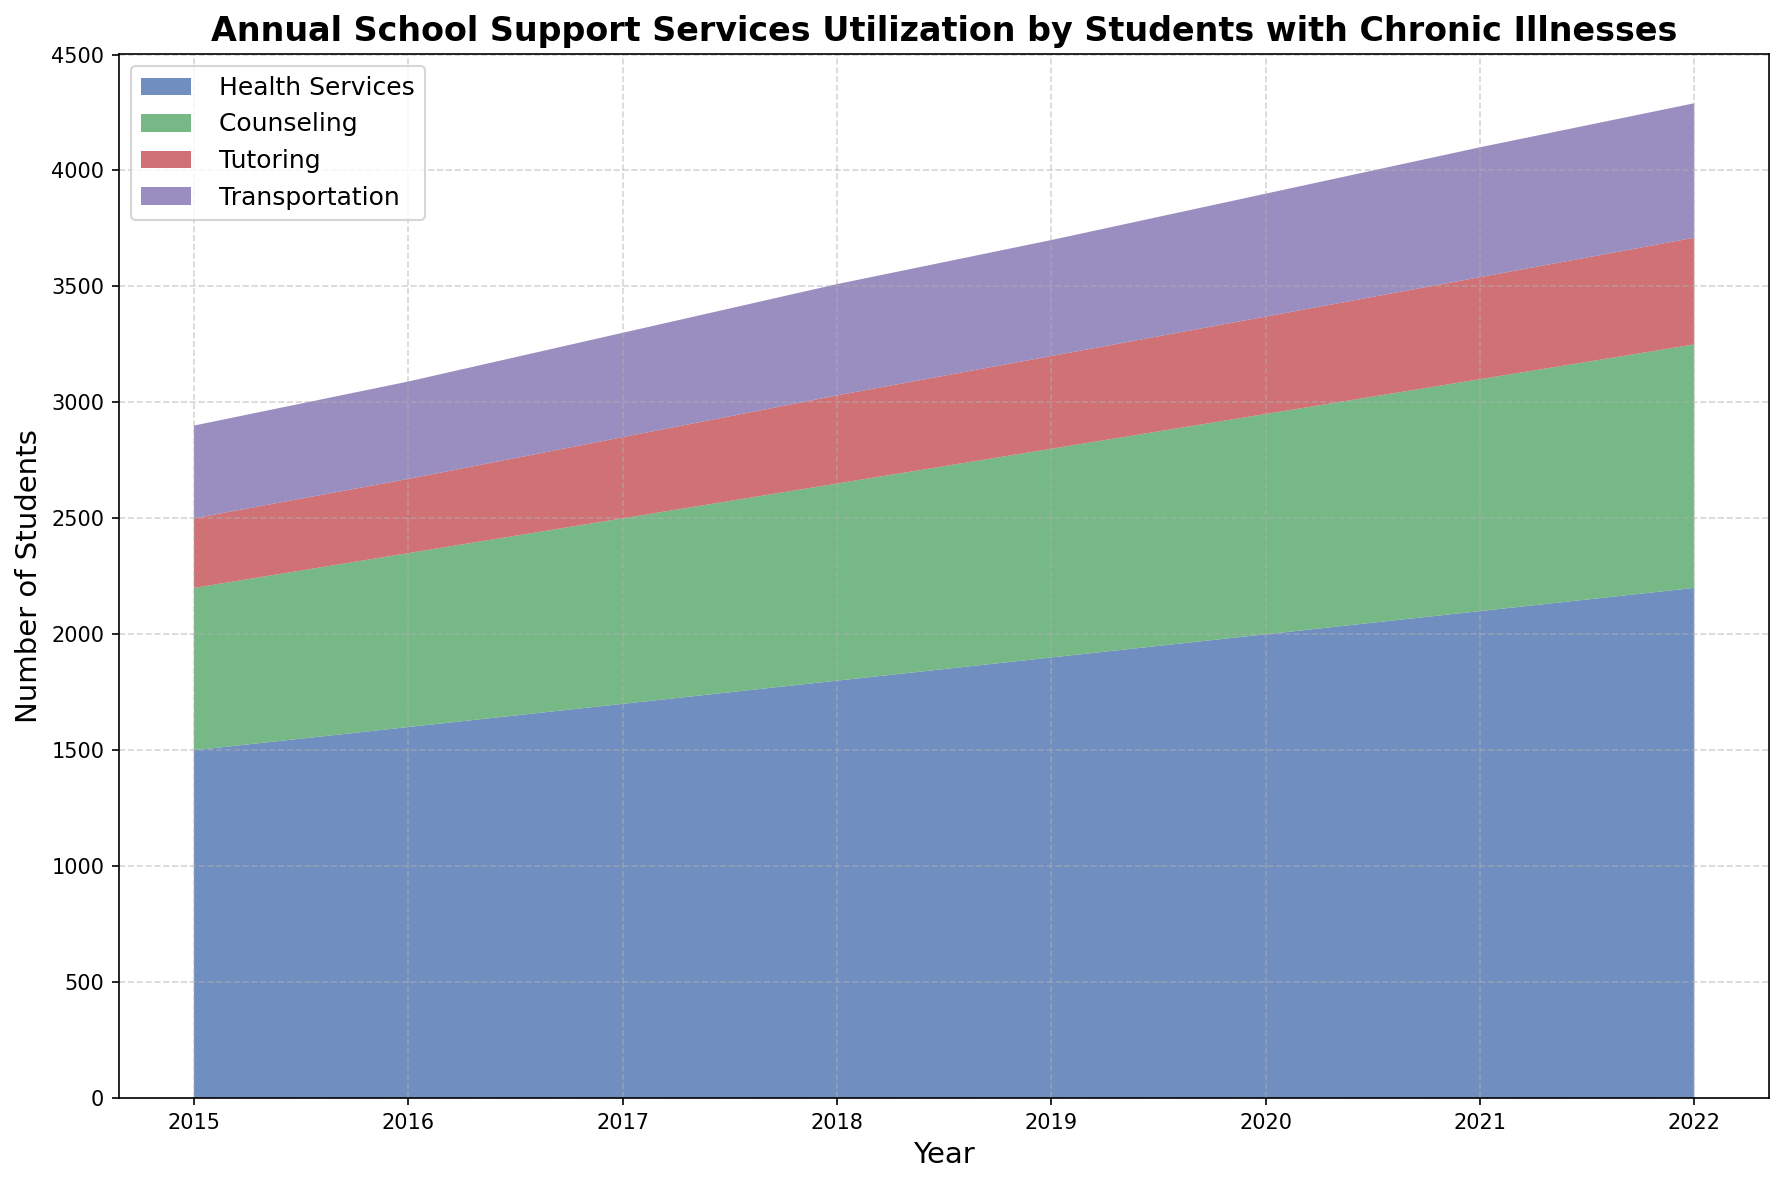What is the overall trend in the utilization of health services over the years? The overall utilization of health services has been increasing consistently from 1500 in 2015 to 2200 in 2022. This indicates a steady upward trend in the need for health services by students with chronic illnesses.
Answer: Increasing Which year had the highest number of students utilizing transportation services? To find the year with the highest number of students utilizing transportation services, look for the peak value in the transportation category. The highest value, 580, is in 2022.
Answer: 2022 By how much did the counseling services increase from 2015 to 2022? To find the increase, subtract the number of students in 2015 from the number in 2022 for counseling services: 1050 (2022) - 700 (2015) = 350.
Answer: 350 Compare the utilization of tutoring and transportation services in 2019. Which category had more students, and by how much? In 2019, tutoring services were utilized by 400 students and transportation services by 500 students. Transport is higher by 500 - 400 = 100 students.
Answer: Transportation by 100 What is the average annual increase in health services utilization from 2015 to 2022? First, find the total increase over the period: 2200 - 1500 = 700. The period spans 7 years, so the average annual increase is 700/7 = 100.
Answer: 100 Which service had the smallest increase in utilization from 2015 to 2022? Compare the increase for each service: Health Services: 2200-1500=700, Counseling: 1050-700=350, Tutoring: 460-300=160, Transportation: 580-400=180. Tutoring had the smallest increase of 160.
Answer: Tutoring What is the ratio of students utilizing health services to counseling services in 2018? Find the values for 2018: 1800 for health services and 850 for counseling. The ratio is 1800:850, which simplifies to approximately 2.12:1.
Answer: 2.12:1 Which year saw the largest single-year increase in the number of students utilizing health services? Look for the largest difference between consecutive years for health services. The biggest increase is between 2021 (2100) and 2022 (2200), a jump of 100 students.
Answer: 2022 What is the cumulative number of students utilizing all services in 2020? Sum the values for all services in 2020: 2000 (Health) + 950 (Counseling) + 420 (Tutoring) + 530 (Transportation) = 3900.
Answer: 3900 How does the trend in tutoring services compare to counseling services from 2015 to 2022? Both tutoring and counseling services demonstrate an upward trend. However, counseling services show a steeper increase from 700 in 2015 to 1050 in 2022, compared to tutoring services which rise from 300 in 2015 to 460 in 2022.
Answer: Counseling shows a steeper increase 